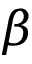<formula> <loc_0><loc_0><loc_500><loc_500>\beta</formula> 